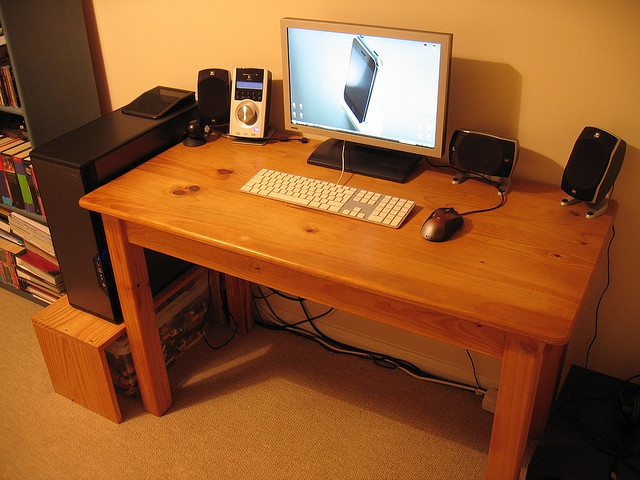Describe the objects in this image and their specific colors. I can see tv in black, white, tan, and lightblue tones, book in black, maroon, tan, and brown tones, keyboard in black, khaki, tan, and brown tones, mouse in black, maroon, brown, and tan tones, and book in black, brown, maroon, tan, and red tones in this image. 